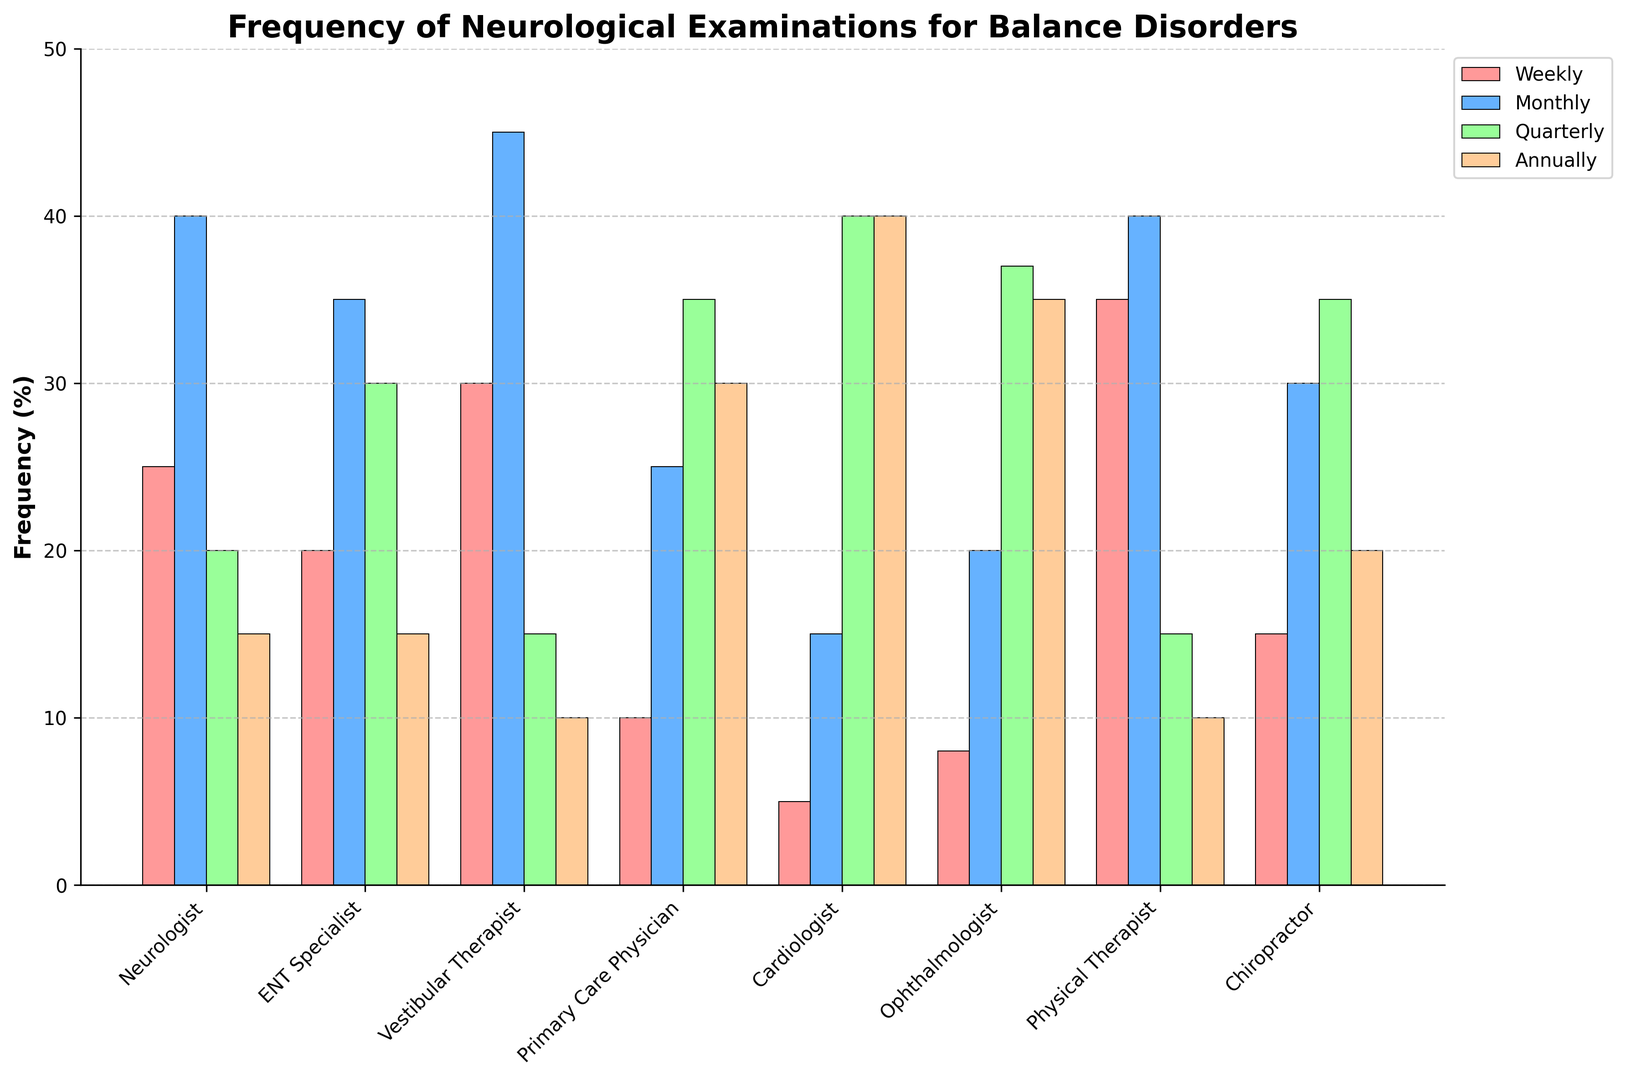Which specialist performs the highest percentage of weekly examinations? The bar representing weekly examinations for all specialists shows that the Physical Therapist's bar is the highest among all.
Answer: Physical Therapist How does the frequency of quarterly examinations compare between Cardiologists and ENT Specialists? The height of the bars for quarterly examinations indicates that Cardiologists perform quarterly examinations more frequently (40%) compared to ENT Specialists (30%).
Answer: Cardiologists perform quarterly examinations more frequently What percentage of monthly examinations are performed by Neurologists? By examining the height of the monthly bar for Neurologists, we can see that it reaches up to 40%.
Answer: 40% Which specialist has the same percentage of annual examinations as Neurologists? By checking the height of the annual bars, it is clear that both Neurologists and ENT Specialists have the same height, which is 15%.
Answer: ENT Specialist Is the number of weekly examinations by Vestibular Therapists greater than the number by ENT Specialists? Comparing the heights of the weekly bars for Vestibular Therapists (30%) and ENT Specialists (20%), Vestibular Therapists perform a higher percentage of weekly examinations.
Answer: Yes What is the total percentage of monthly and quarterly examinations performed by Primary Care Physicians? Adding the percentages of monthly (25%) and quarterly (35%) examinations gives a total of 60%.
Answer: 60% Among Neurologists, ENT Specialists, and Primary Care Physicians, who performs the least annual examinations? By comparing the annual bar heights, the Neurologists, ENT Specialists, and Primary Care Physicians have annual examinations of 15%, 15%, and 30% respectively. The Neurologists and ENT Specialists perform the least, with 15%.
Answer: Neurologists and ENT Specialists What is the difference in the percentage of quarterly examinations between Neurologists and Primary Care Physicians? Subtracting the Neurologists' quarterly examinations (20%) from Primary Care Physicians' quarterly examinations (35%) gives a difference of 15%.
Answer: 15% How do the weekly examination percentages of Physical Therapists and Chiropractors compare? The height of the weekly bars shows Physical Therapists at 35% and Chiropractors at 15%, meaning Physical Therapists perform a higher percentage of weekly examinations.
Answer: Physical Therapists perform more Who performs more monthly examinations, ENT Specialists or Ophthalmologists? By comparing the monthly bars, ENT Specialists have a higher percentage (35%) than Ophthalmologists (20%).
Answer: ENT Specialists 